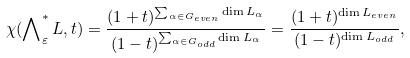Convert formula to latex. <formula><loc_0><loc_0><loc_500><loc_500>\chi ( \bigwedge \nolimits _ { \varepsilon } ^ { * } L , t ) = \frac { ( 1 + t ) ^ { \sum _ { \alpha \in G _ { e v e n } } \dim L _ { \alpha } } } { ( 1 - t ) ^ { \sum _ { \alpha \in G _ { o d d } } \dim L _ { \alpha } } } = \frac { ( 1 + t ) ^ { \dim L _ { e v e n } } } { ( 1 - t ) ^ { \dim L _ { o d d } } } ,</formula> 